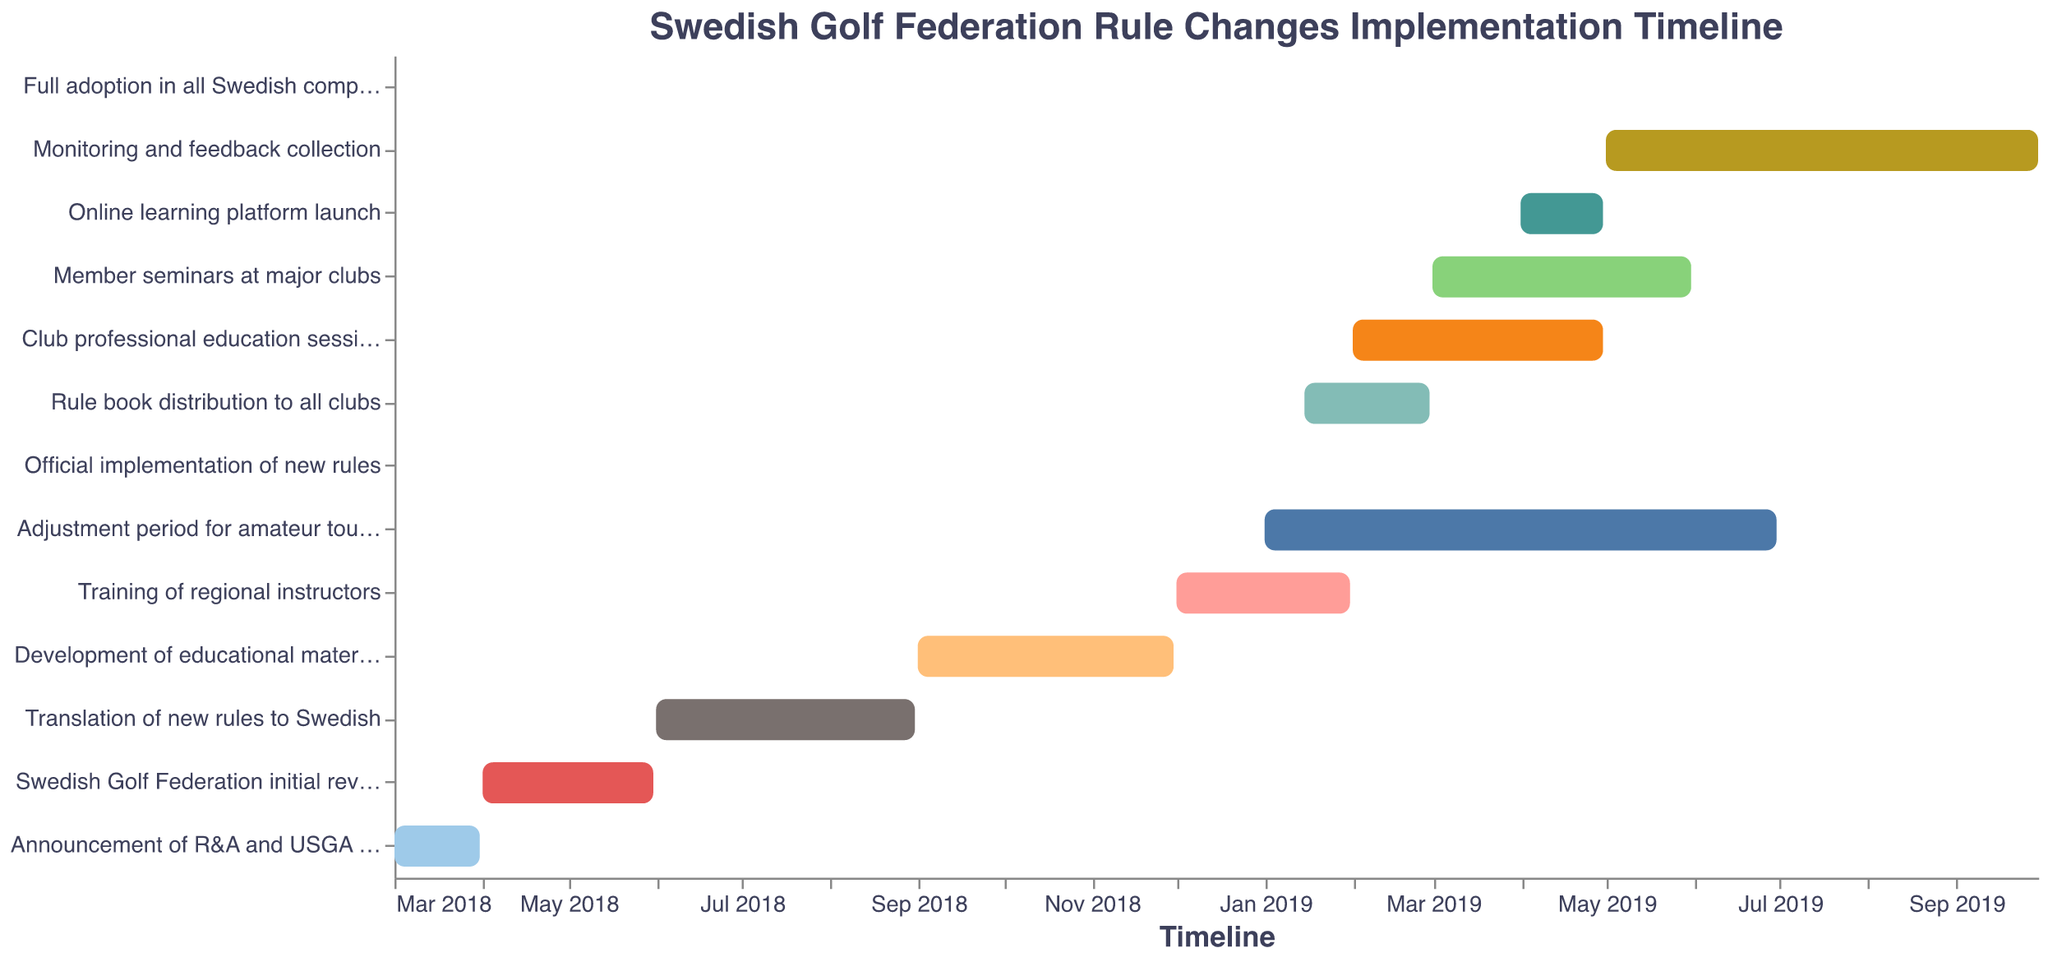When was the "Official implementation of new rules"? The timeline for "Official implementation of new rules" shows it was implemented on January 1, 2019.
Answer: January 1, 2019 Which task started first in the timeline? According to the timeline, the "Announcement of R&A and USGA rule changes" task began the earliest, starting on March 1, 2018.
Answer: "Announcement of R&A and USGA rule changes" Which tasks were taking place during April 2019? The chart shows that "Club professional education sessions", "Member seminars at major clubs", and "Online learning platform launch" were all ongoing in April 2019.
Answer: "Club professional education sessions", "Member seminars at major clubs", "Online learning platform launch" How long did the "Translation of new rules to Swedish" task take? The "Translation of new rules to Swedish" task started on June 1, 2018, and ended on August 31, 2018, taking a total of 3 months.
Answer: 3 months What is the duration between the start of "Swedish Golf Federation initial review" and the "Full adoption in all Swedish competitions"? "Swedish Golf Federation initial review" begins on April 1, 2018, and "Full adoption in all Swedish competitions" occurs on July 1, 2019. The duration in between these dates is approximately 15 months.
Answer: 15 months Which task followed immediately after the "Development of educational materials"? The next task after the "Development of educational materials" is "Training of regional instructors", which starts on December 1, 2018.
Answer: "Training of regional instructors" How many tasks were conducted in 2019? There are 9 tasks in the timeline that were conducted at least partially in 2019: "Training of regional instructors", "Official implementation of new rules", "Rule book distribution to all clubs", "Club professional education sessions", "Member seminars at major clubs", "Online learning platform launch", "Monitoring and feedback collection", "Adjustment period for amateur tournaments", and "Full adoption in all Swedish competitions".
Answer: 9 tasks Which task had the longest duration? The "Adjustment period for amateur tournaments" lasted the longest, from January 1, 2019, to June 30, 2019, a total of 6 months.
Answer: "Adjustment period for amateur tournaments" 